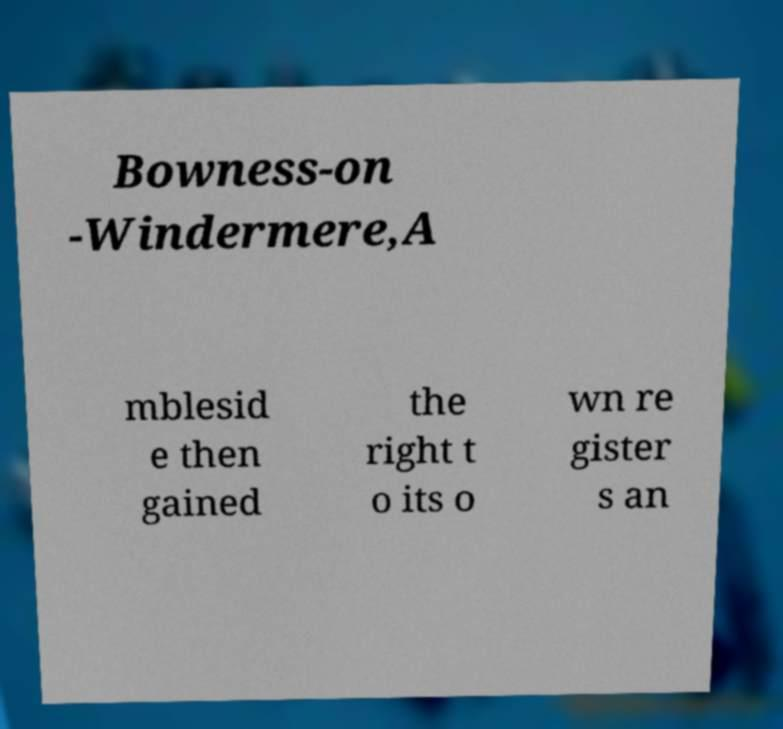Could you extract and type out the text from this image? Bowness-on -Windermere,A mblesid e then gained the right t o its o wn re gister s an 